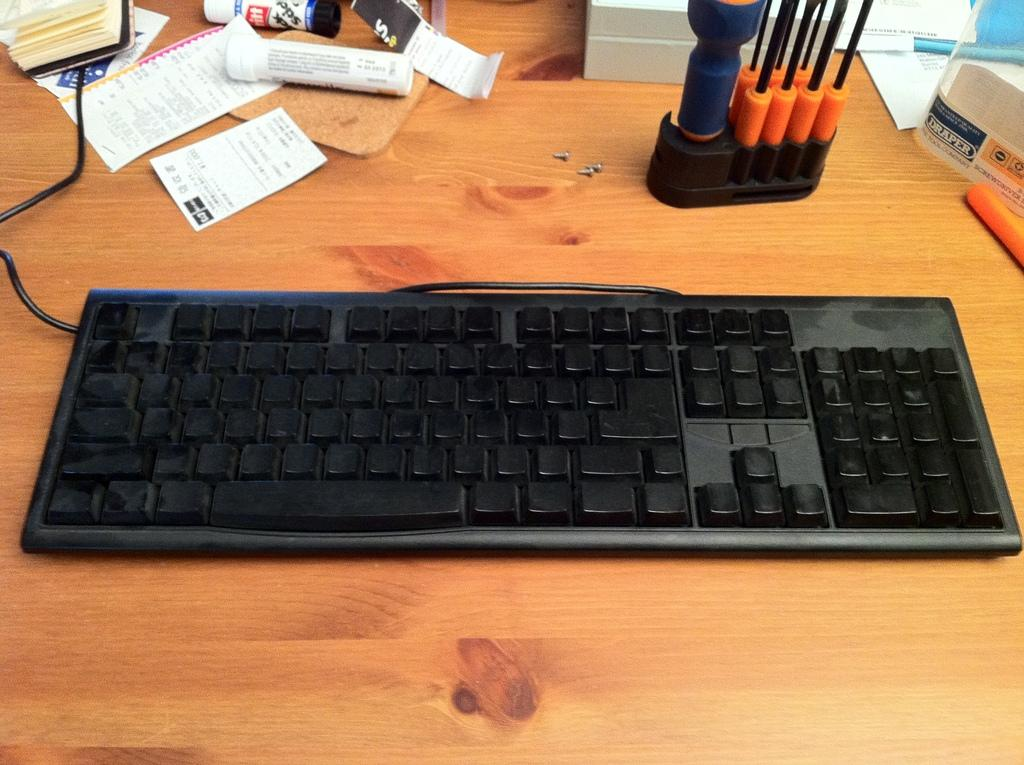<image>
Render a clear and concise summary of the photo. A desk with a keyboard and screw driver and paper labeled draper 